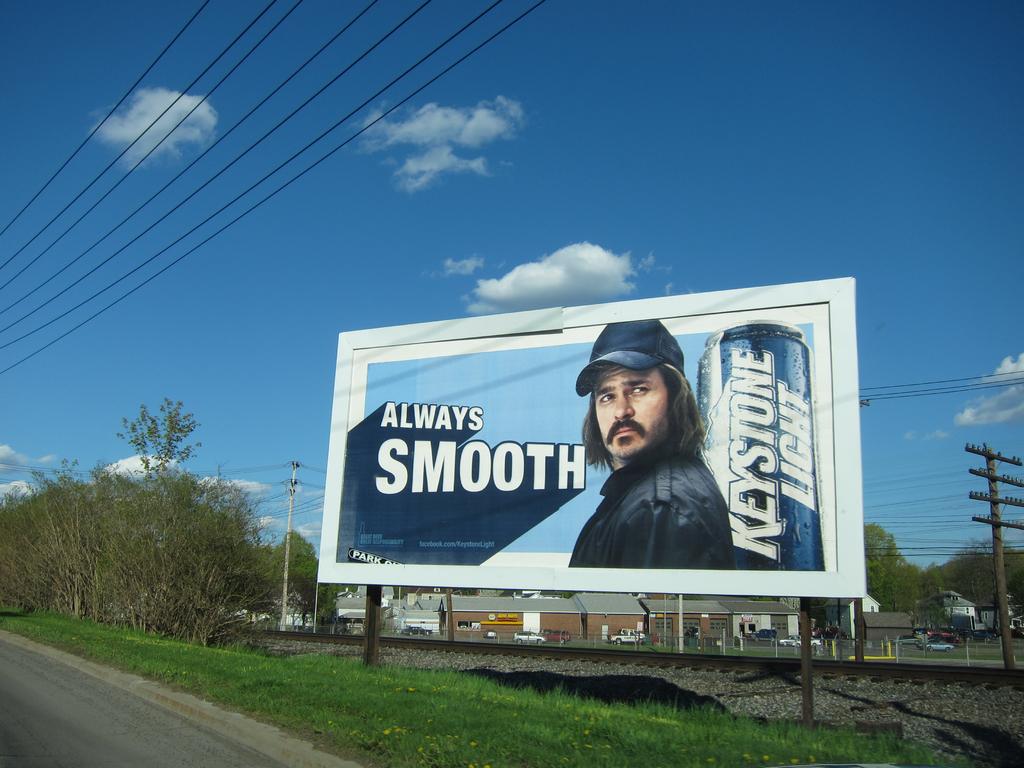What does it say this beer is?
Offer a very short reply. Always smooth. What is the name of the brand of beer?
Provide a succinct answer. Keystone light. 